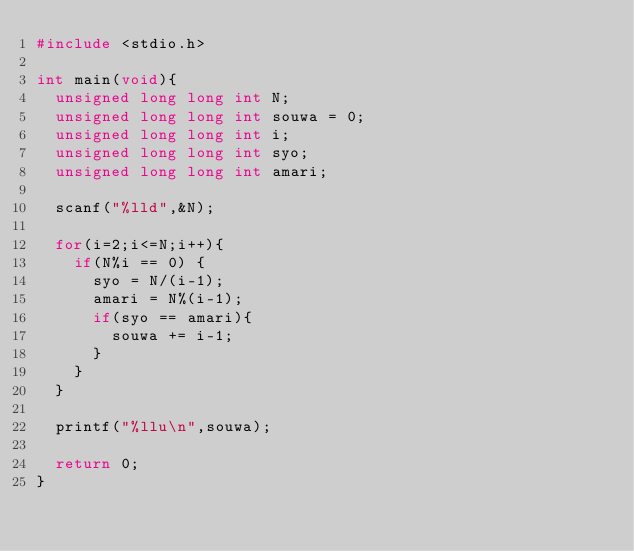<code> <loc_0><loc_0><loc_500><loc_500><_C_>#include <stdio.h>

int main(void){
  unsigned long long int N;
  unsigned long long int souwa = 0;
  unsigned long long int i;
  unsigned long long int syo;
  unsigned long long int amari;

  scanf("%lld",&N);

  for(i=2;i<=N;i++){
    if(N%i == 0) {
      syo = N/(i-1);
      amari = N%(i-1);
      if(syo == amari){
        souwa += i-1;
      }
    }
  }

  printf("%llu\n",souwa);

  return 0;
}
</code> 